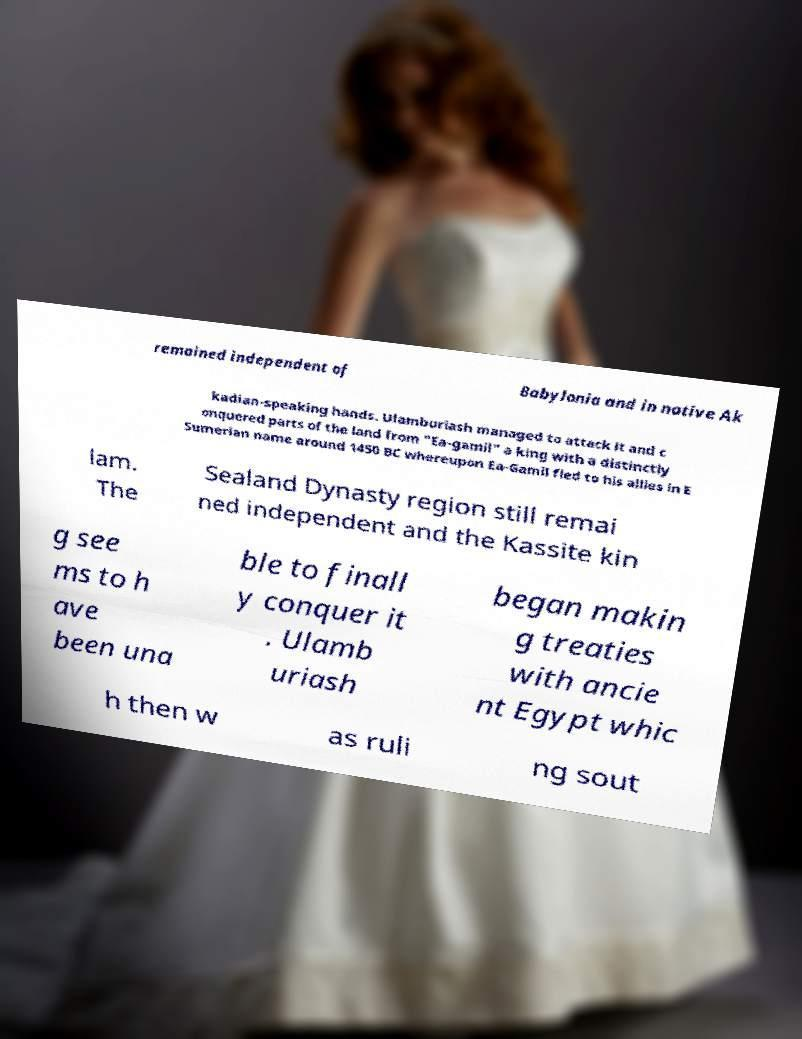For documentation purposes, I need the text within this image transcribed. Could you provide that? remained independent of Babylonia and in native Ak kadian-speaking hands. Ulamburiash managed to attack it and c onquered parts of the land from "Ea-gamil" a king with a distinctly Sumerian name around 1450 BC whereupon Ea-Gamil fled to his allies in E lam. The Sealand Dynasty region still remai ned independent and the Kassite kin g see ms to h ave been una ble to finall y conquer it . Ulamb uriash began makin g treaties with ancie nt Egypt whic h then w as ruli ng sout 